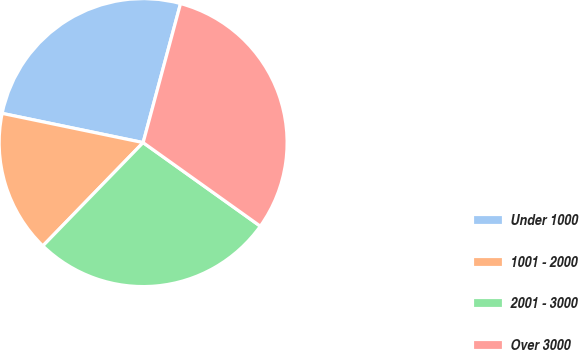Convert chart to OTSL. <chart><loc_0><loc_0><loc_500><loc_500><pie_chart><fcel>Under 1000<fcel>1001 - 2000<fcel>2001 - 3000<fcel>Over 3000<nl><fcel>25.93%<fcel>15.99%<fcel>27.4%<fcel>30.68%<nl></chart> 